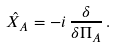Convert formula to latex. <formula><loc_0><loc_0><loc_500><loc_500>\hat { X } _ { A } = - i \, \frac { \delta } { \delta \Pi _ { A } } \, .</formula> 